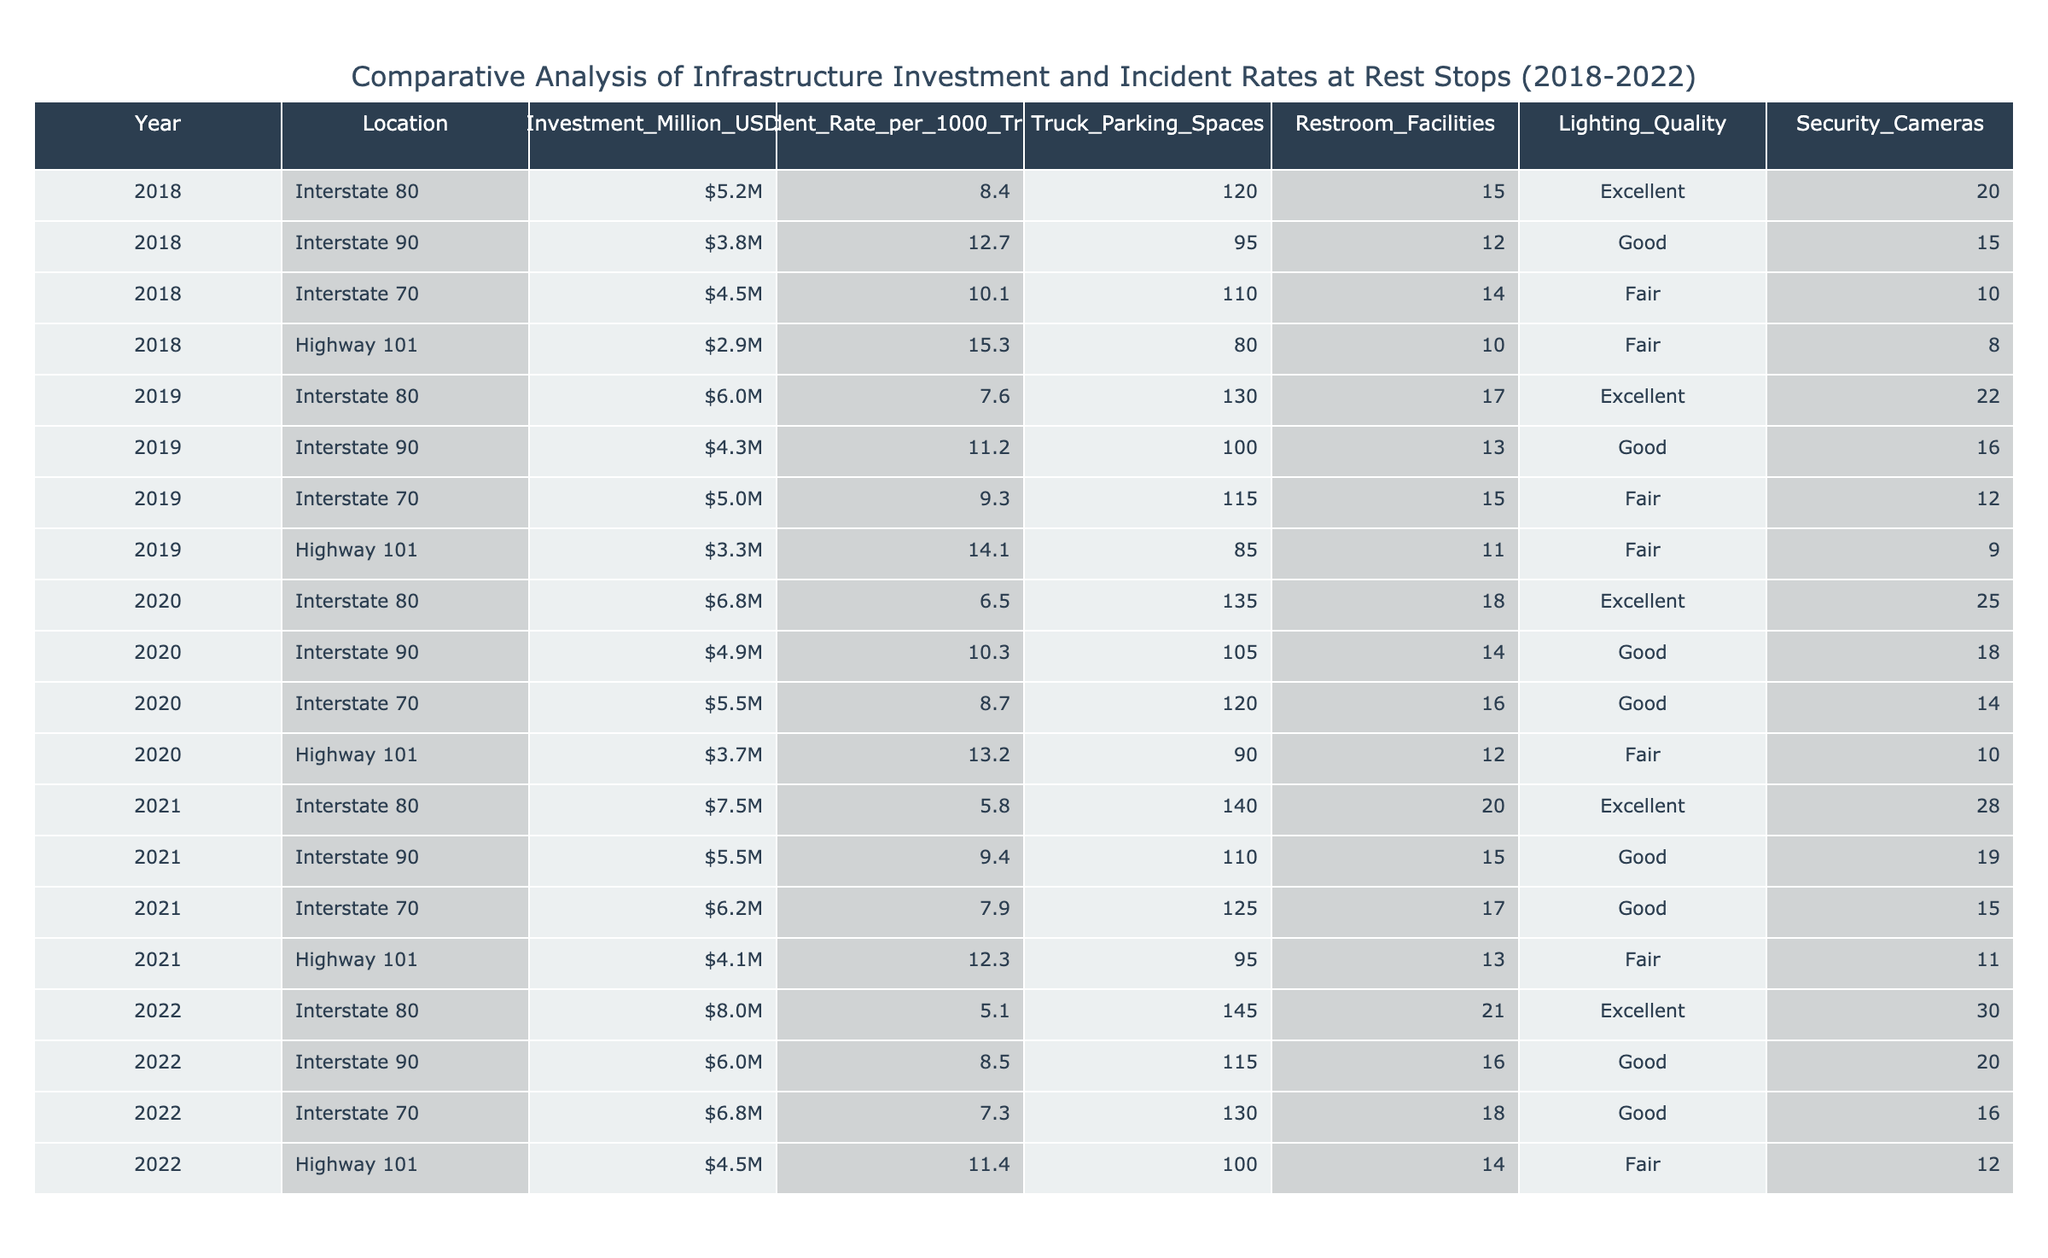What was the investment amount for Interstate 80 in 2020? From the table, we can directly look for the row corresponding to 2020 and the location Interstate 80. The value in the Investment_Million_USD column for that row is 6.8 million USD.
Answer: 6.8 million USD Which location had the highest incident rate in 2019? Looking at the Incident_Rate_per_1000_Trucks column for the year 2019, I can compare the values of each location. The highest value found is 14.1 at Highway 101.
Answer: Highway 101 What is the total investment for Interstate 90 over the five years? To find the total investment for Interstate 90, I sum up the Investment_Million_USD values for each year from 2018 to 2022: 3.8 + 4.3 + 4.9 + 5.5 + 6.0 = 24.5 million USD.
Answer: 24.5 million USD Did the incident rate for Interstate 70 decrease from 2018 to 2022? Checking the Incident_Rate_per_1000_Trucks column, for 2018 the value is 10.1 and for 2022, it is 7.3. Comparing these, the incident rate decreased from 10.1 to 7.3 over the four years.
Answer: Yes What is the average number of truck parking spaces at all locations in 2021? I find the Truck_Parking_Spaces for each location in 2021: 140 + 110 + 125 + 95 = 470. There are four locations in 2021, so the average is 470 / 4 = 117.5 spaces.
Answer: 117.5 spaces Which year showed the greatest improvement in incident rate for Interstate 80? I analyze the Incident_Rate_per_1000_Trucks for Interstate 80 across the years: 8.4 (2018), 7.6 (2019), 6.5 (2020), 5.8 (2021), 5.1 (2022). The greatest improvement occurs from 2018 to 2022, decreasing by 3.3 points (from 8.4 to 5.1).
Answer: 2018 to 2022 How many restroom facilities were available at Highway 101 in 2020? By locating the row for Highway 101 in 2020, I find the value under Restroom_Facilities, which is 12.
Answer: 12 Was there a consistent increase in investment amounts from 2018 to 2022? Reviewing the Investment_Million_USD for each year, the values are: 5.2 (2018), 6.0 (2019), 6.8 (2020), 7.5 (2021), and 8.0 (2022). All values show an upward trend, indicating a consistent increase in investment.
Answer: Yes 